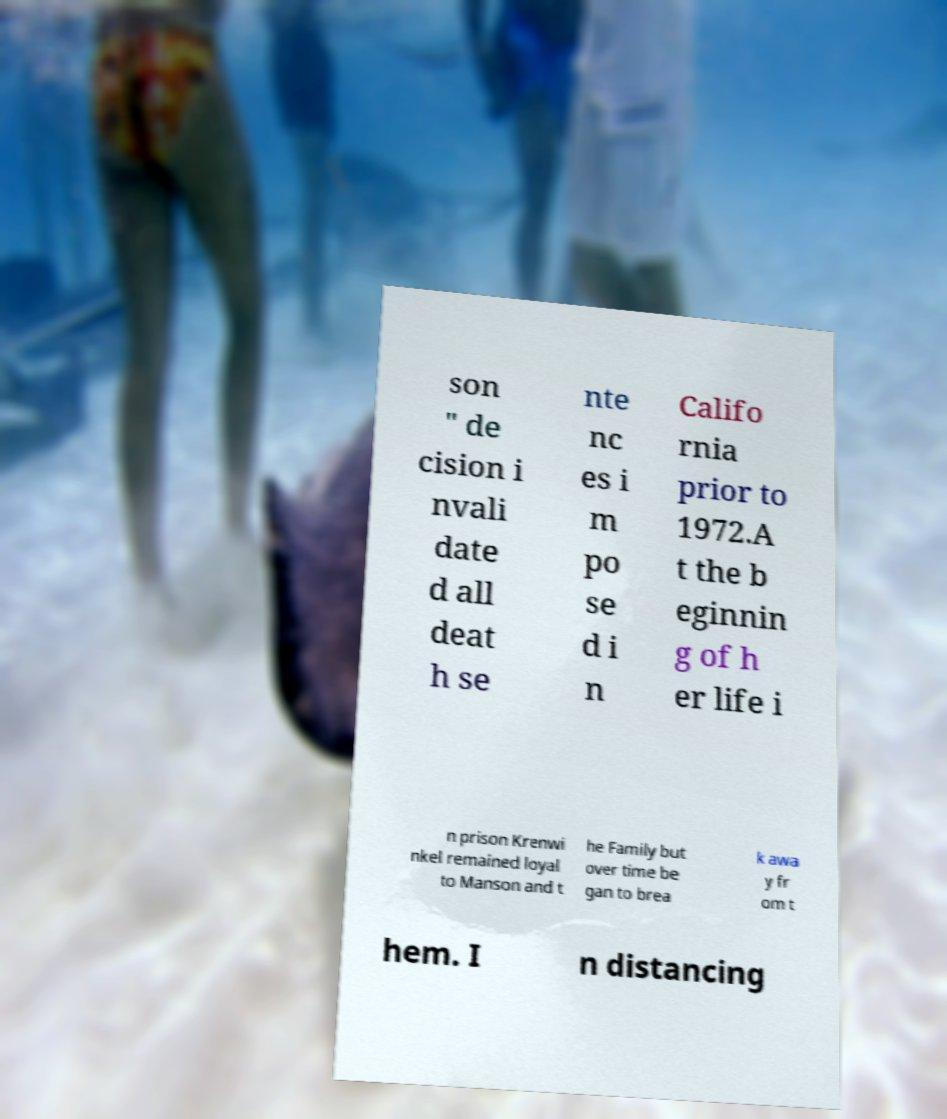Please read and relay the text visible in this image. What does it say? son " de cision i nvali date d all deat h se nte nc es i m po se d i n Califo rnia prior to 1972.A t the b eginnin g of h er life i n prison Krenwi nkel remained loyal to Manson and t he Family but over time be gan to brea k awa y fr om t hem. I n distancing 